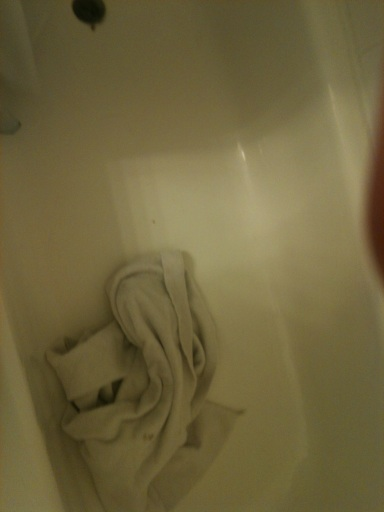Can you tell what type of towel is in the bathtub? It appears to be a white bath towel. Typically, these towels are used after bathing and should be kept in a clean and dry place to maintain hygiene. How should the towel be stored instead? The towel should be hung on a towel rack or bar to air dry after use. If it's dirty, it should be placed in a laundry basket or taken directly to the washing machine. 